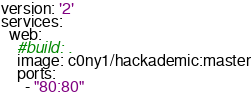Convert code to text. <code><loc_0><loc_0><loc_500><loc_500><_YAML_>version: '2'
services:
  web:
    #build: .
    image: c0ny1/hackademic:master
    ports:
      - "80:80"
</code> 